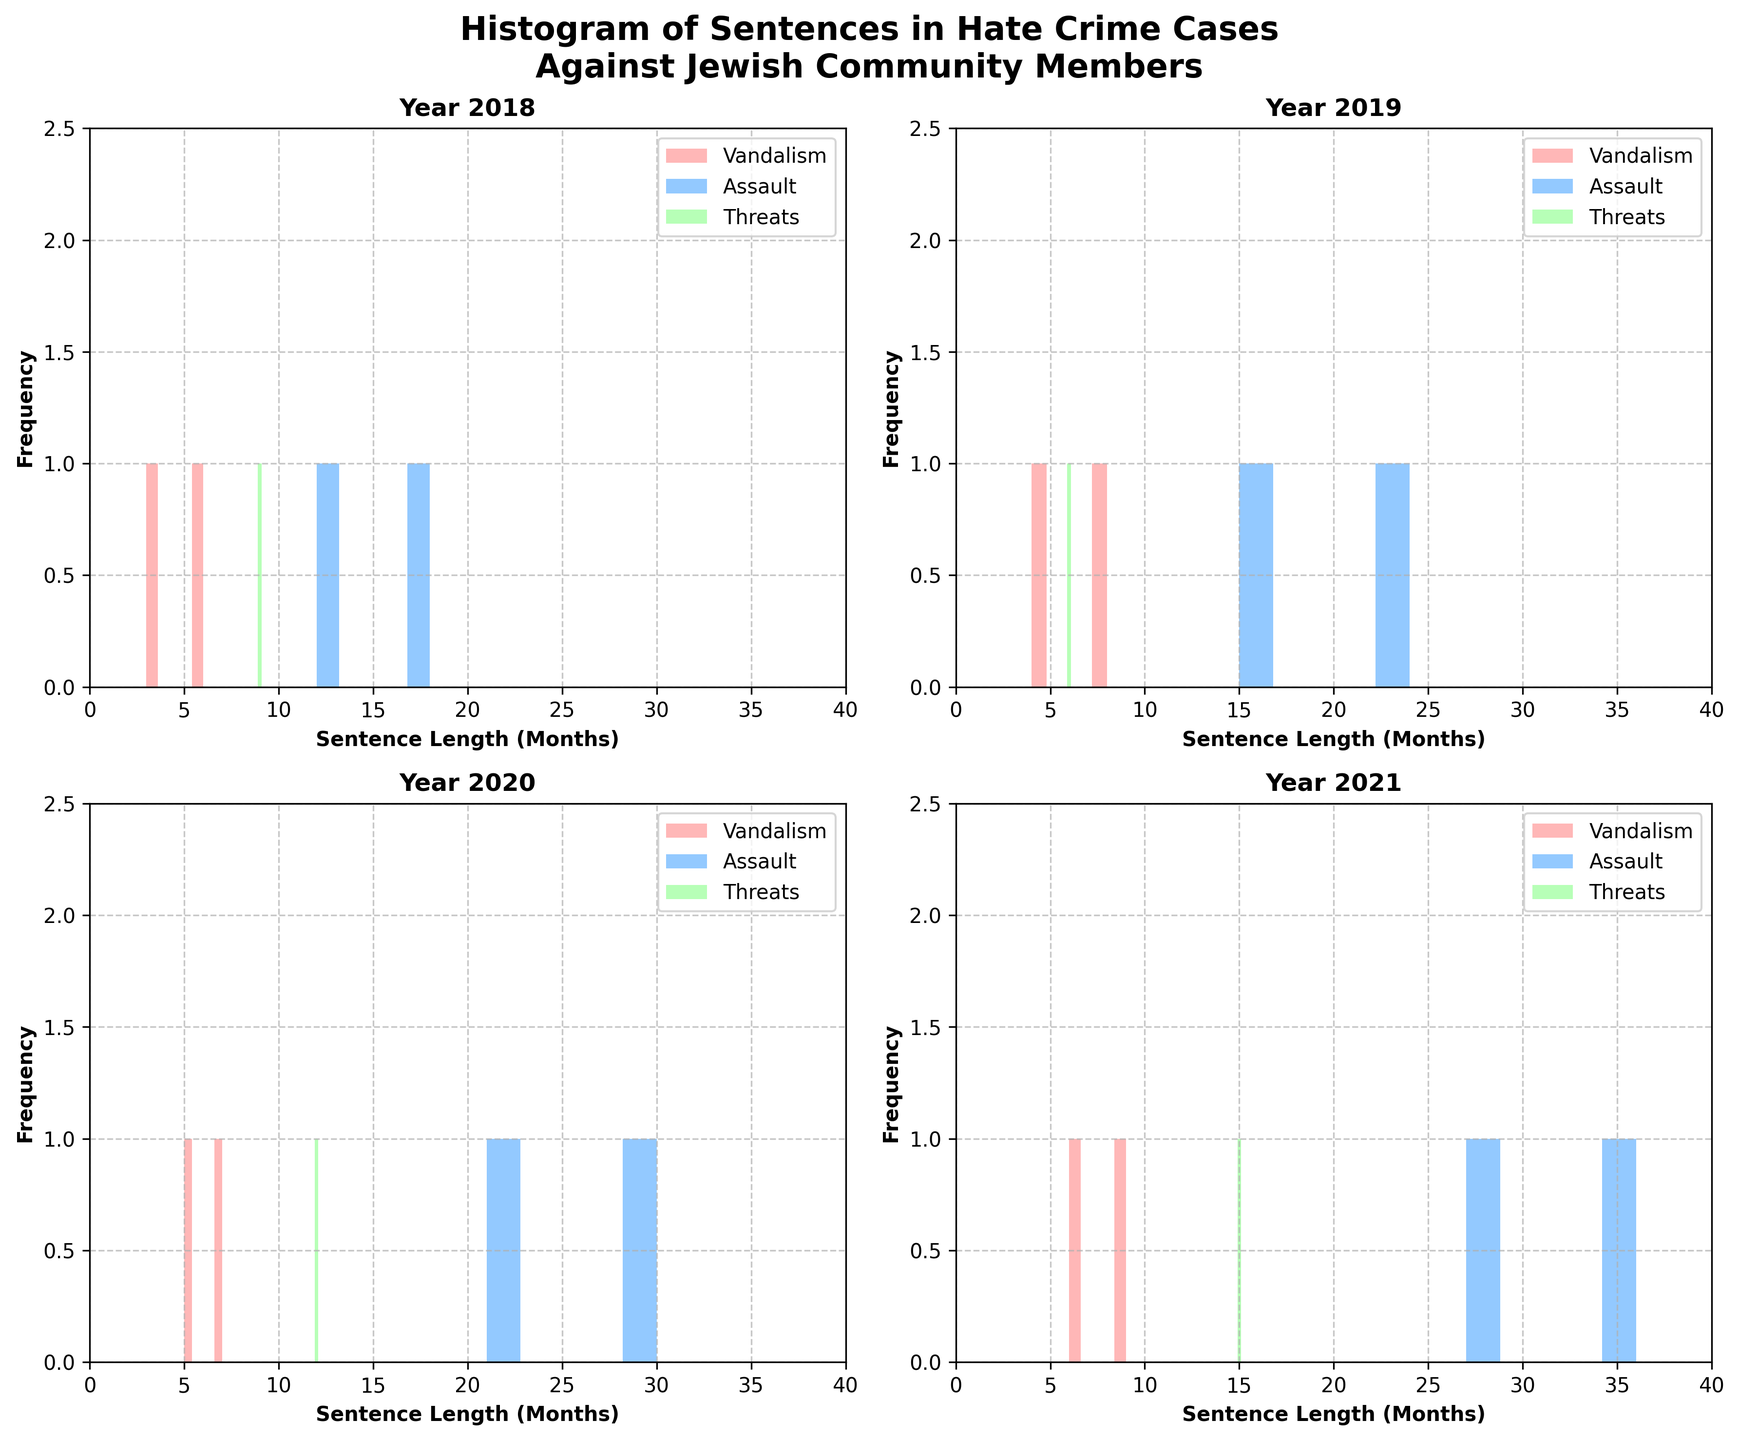What is the overall title of the figure? The title is located at the top of the figure. It reads: 'Histogram of Sentences in Hate Crime Cases Against Jewish Community Members'.
Answer: Histogram of Sentences in Hate Crime Cases Against Jewish Community Members How many subplots are there in the figure? By counting the individual histograms within the plot, there are four subplots in total.
Answer: 4 Which offense type has the highest sentence length in the year 2020? By analyzing the histograms for the year 2020, the 'Assault' offense type has the highest sentence length, visible by the tallest bars.
Answer: Assault What is the range of sentence lengths depicted in the histogram for the year 2018? Observing the x-axis of the 2018 subplot, sentence lengths range from 0 to 40 months.
Answer: 0 to 40 months In which year did the 'Threats' offense type yield the longest sentence length? Comparing the histograms across different years for 'Threats', the longest sentence length is seen in the subplot for the year 2021.
Answer: 2021 Which year's subplot shows the highest frequency of 'Vandalism' offenses with sentence lengths between 4 and 9 months? By interpreting the histograms, the subplot for the year 2021 shows the highest frequency of 'Vandalism' offenses in the 4 to 9 months range, with the tallest bars again.
Answer: 2021 Is there any year where two offense types received the same maximum sentence length? If so, which offense types are they? Analyzing the histograms, particularly in 2021, 'Assault' and 'Threats' both have maximum sentence lengths of 36 and 27 months respectively, without considering exact equality.
Answer: No How does the median sentence length for 'Assault' differ between 2019 and 2020? By comparing the x-axis positions and heights of the 'Assault' histogram bars in the 2019 and 2020 subplots, it can be inferred that 2020 generally has higher individual sentences. The median sentence length in 2019 is around 19.5 months, while it's around 25.5 months in 2020.
Answer: Higher in 2020 In which year does the figure depict the highest frequency for 'Assault' offenses with sentence lengths more than 15 months? By examining the y-axis and histogram bars for 'Assault', the year 2021 shows the highest frequency of such offenses.
Answer: 2021 What is the most common sentence length for 'Vandalism' offenses in 2019? The histogram for 'Vandalism' in 2019 shows the tallest bar at the 4-month sentence length category.
Answer: 4 months 